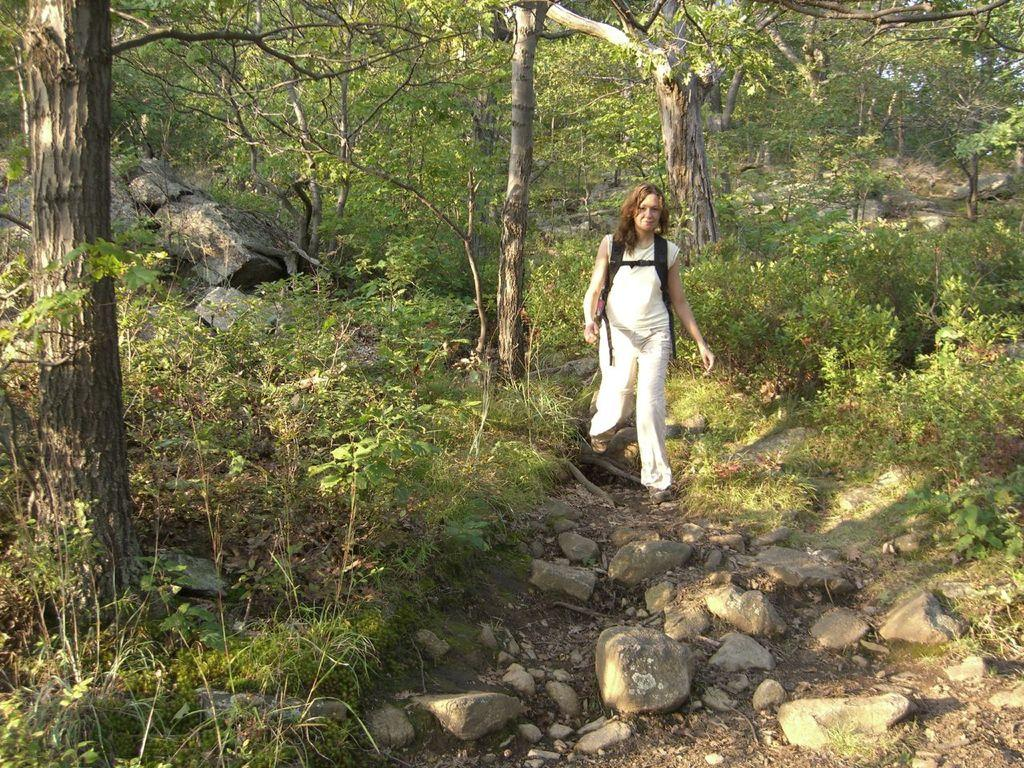What is the person in the image doing? There is a person walking in the image. What is the person wearing? The person is wearing a white dress. What can be seen in the background of the image? There are rocks and trees with green color in the background of the image. What type of good-bye is the person saying in the image? There is no indication in the image that the person is saying good-bye or engaging in any verbal communication. --- 